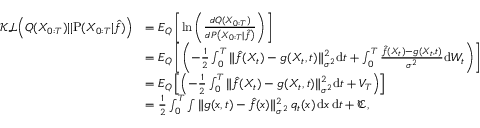Convert formula to latex. <formula><loc_0><loc_0><loc_500><loc_500>\begin{array} { r l } { \mathcal { K L } \left ( Q ( X _ { 0 \colon T } ) | | P ( X _ { 0 \colon T } | \hat { f } ) \right ) } & { = E _ { Q } \left [ \ln \left ( \frac { d { Q } ( X _ { 0 \colon T } ) } { d { P } \left ( X _ { 0 \colon T } | \hat { f } \right ) } \right ) \right ] } \\ & { = E _ { Q } \left [ \left ( - \frac { 1 } { 2 } \int _ { 0 } ^ { T } { { \| \hat { f } ( X _ { t } ) - g ( X _ { t } , t ) \| _ { \sigma ^ { 2 } } ^ { 2 } } d t } + \int _ { 0 } ^ { T } { \frac { \hat { f } ( X _ { t } ) - g ( X _ { t } , t ) } { { \sigma ^ { 2 } } } d W _ { t } } \right ) \right ] } \\ & { = E _ { Q } \left [ \left ( - \frac { 1 } { 2 } \int _ { 0 } ^ { T } { { \| \hat { f } ( X _ { t } ) - g ( X _ { t } , t ) \| _ { \sigma ^ { 2 } } ^ { 2 } } d t } + V _ { T } \right ) \right ] } \\ & { = \frac { 1 } { 2 } \int _ { 0 } ^ { T } \int \| g ( x , t ) - \hat { f } ( x ) \| _ { \sigma ^ { 2 } } ^ { 2 } \, q _ { t } ( x ) \, d x \, d t + \mathfrak { C } , } \end{array}</formula> 